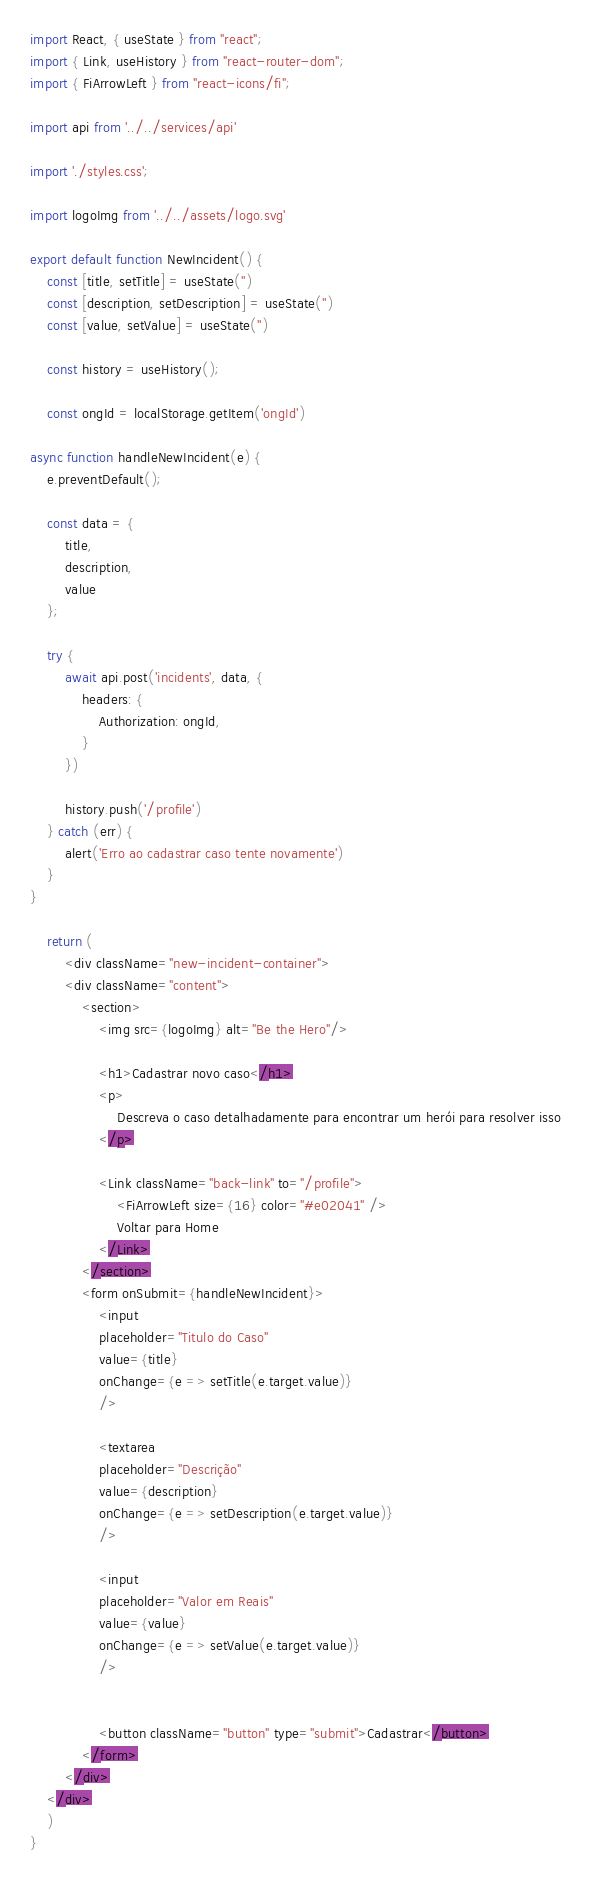Convert code to text. <code><loc_0><loc_0><loc_500><loc_500><_JavaScript_>import React, { useState } from "react";
import { Link, useHistory } from "react-router-dom";
import { FiArrowLeft } from "react-icons/fi";

import api from '../../services/api'

import './styles.css';

import logoImg from '../../assets/logo.svg'

export default function NewIncident() {
    const [title, setTitle] = useState('')
    const [description, setDescription] = useState('')
    const [value, setValue] = useState('')

    const history = useHistory();

    const ongId = localStorage.getItem('ongId')

async function handleNewIncident(e) {
    e.preventDefault();

    const data = {
        title,
        description,
        value
    };

    try {
        await api.post('incidents', data, {
            headers: {
                Authorization: ongId,
            }
        })

        history.push('/profile')
    } catch (err) {
        alert('Erro ao cadastrar caso tente novamente')
    }
}

    return (
        <div className="new-incident-container">
        <div className="content">
            <section>
                <img src={logoImg} alt="Be the Hero"/>

                <h1>Cadastrar novo caso</h1>
                <p>
                    Descreva o caso detalhadamente para encontrar um herói para resolver isso
                </p>

                <Link className="back-link" to="/profile">
                    <FiArrowLeft size={16} color="#e02041" />
                    Voltar para Home
                </Link>
            </section>
            <form onSubmit={handleNewIncident}>
                <input 
                placeholder="Titulo do Caso"
                value={title}
                onChange={e => setTitle(e.target.value)}                
                />

                <textarea 
                placeholder="Descrição" 
                value={description}
                onChange={e => setDescription(e.target.value)} 
                />

                <input 
                placeholder="Valor em Reais" 
                value={value}
                onChange={e => setValue(e.target.value)} 
                />


                <button className="button" type="submit">Cadastrar</button>
            </form>
        </div>
    </div>
    )
}</code> 